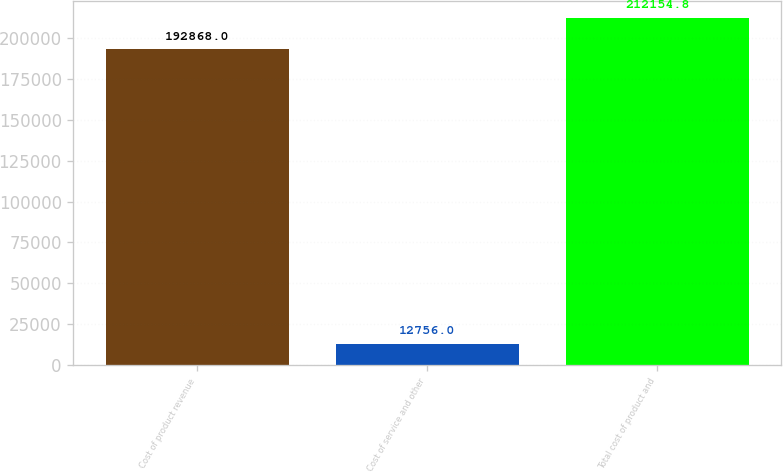<chart> <loc_0><loc_0><loc_500><loc_500><bar_chart><fcel>Cost of product revenue<fcel>Cost of service and other<fcel>Total cost of product and<nl><fcel>192868<fcel>12756<fcel>212155<nl></chart> 